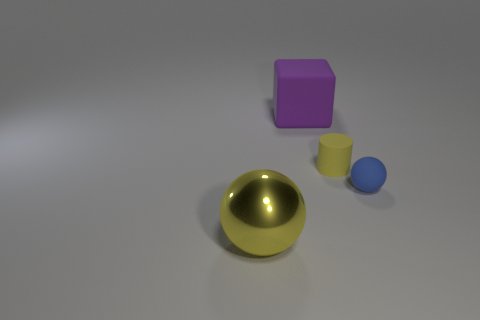How many other objects are there of the same shape as the purple matte object?
Ensure brevity in your answer.  0. Is the shape of the yellow thing that is left of the tiny yellow thing the same as the small matte thing in front of the yellow rubber cylinder?
Your response must be concise. Yes. Are there the same number of matte cylinders that are right of the tiny yellow matte object and objects that are behind the blue object?
Offer a terse response. No. The rubber object that is on the right side of the yellow object that is behind the ball in front of the blue object is what shape?
Give a very brief answer. Sphere. Does the yellow object that is on the right side of the big purple object have the same material as the sphere that is behind the yellow ball?
Your answer should be very brief. Yes. What is the shape of the object that is behind the small cylinder?
Keep it short and to the point. Cube. Are there fewer blue metal blocks than big objects?
Ensure brevity in your answer.  Yes. There is a large object right of the ball that is to the left of the purple object; is there a big yellow shiny sphere that is on the left side of it?
Make the answer very short. Yes. How many metallic objects are either purple blocks or tiny purple cylinders?
Give a very brief answer. 0. Is the color of the shiny object the same as the matte cylinder?
Offer a very short reply. Yes. 